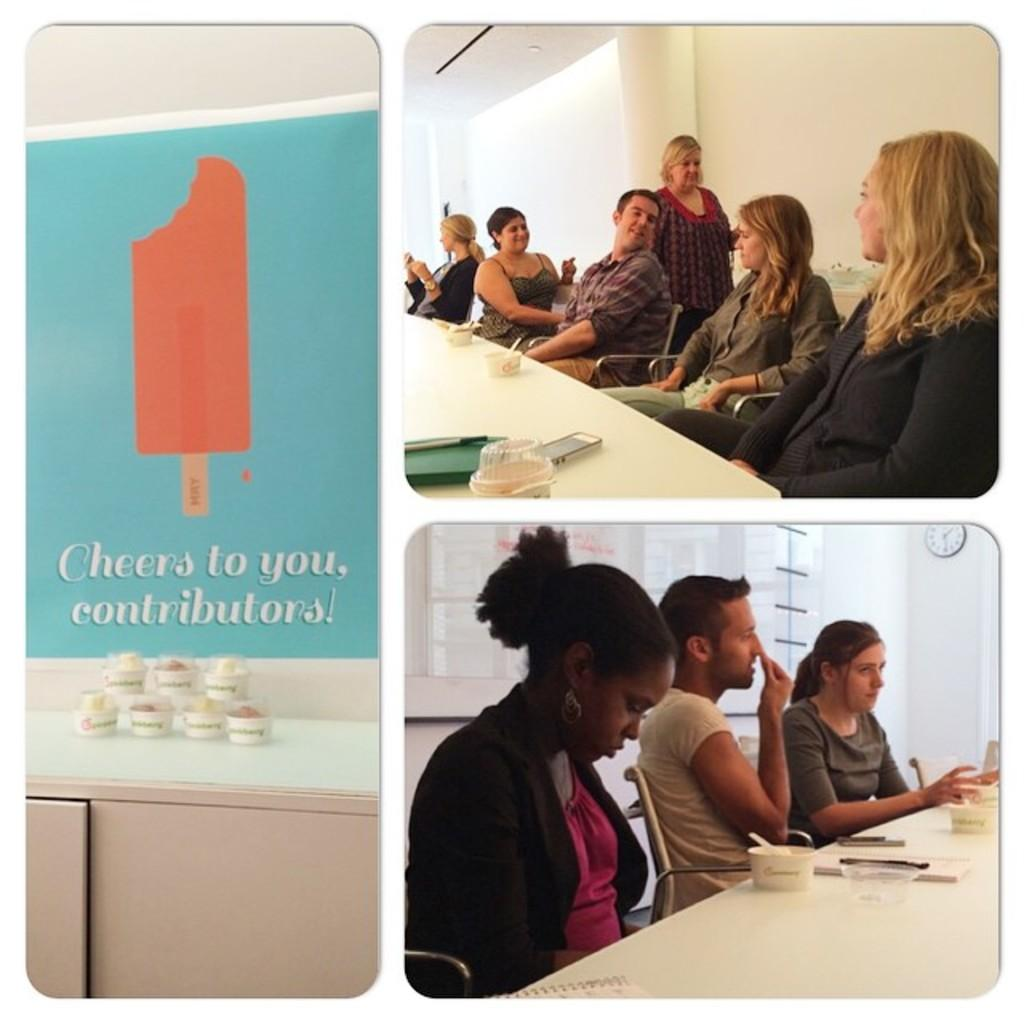What are the people in the image doing? The people in the image are sitting on chairs. What is on the table in the image? There is a bowl, a book, and a mobile on the table in the image. What type of clam is being cooked in the bowl on the table? There is no clam present in the image; the bowl contains unspecified contents. 